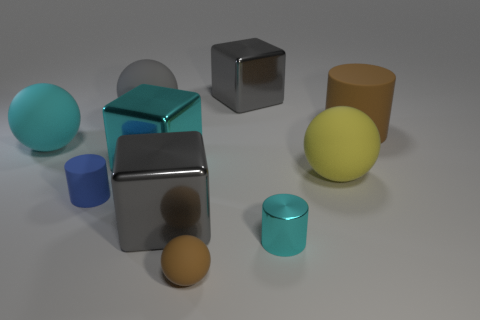Add 9 small yellow matte objects. How many small yellow matte objects exist? 9 Subtract all gray cubes. How many cubes are left? 1 Subtract all cyan metallic blocks. How many blocks are left? 2 Subtract 1 yellow balls. How many objects are left? 9 Subtract all cylinders. How many objects are left? 7 Subtract 1 blocks. How many blocks are left? 2 Subtract all red cubes. Subtract all cyan spheres. How many cubes are left? 3 Subtract all red cylinders. How many gray blocks are left? 2 Subtract all yellow objects. Subtract all big yellow rubber spheres. How many objects are left? 8 Add 2 brown cylinders. How many brown cylinders are left? 3 